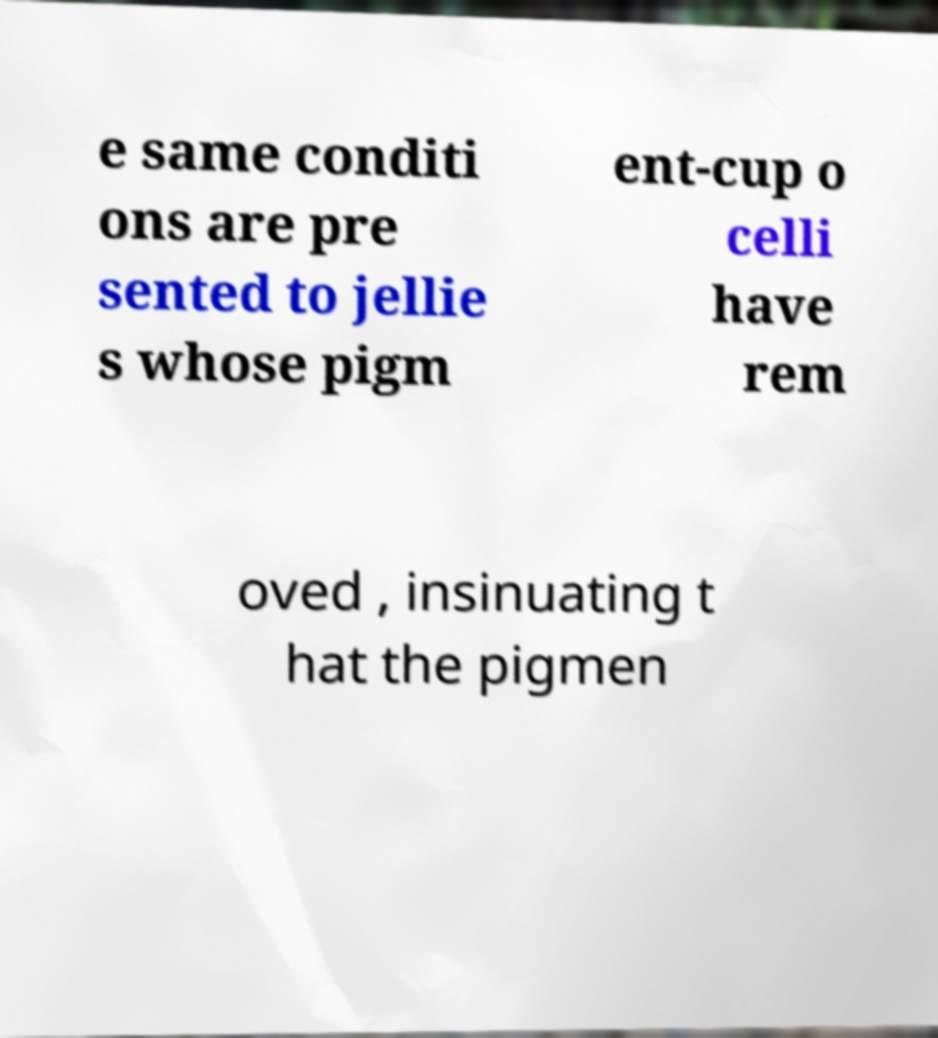I need the written content from this picture converted into text. Can you do that? e same conditi ons are pre sented to jellie s whose pigm ent-cup o celli have rem oved , insinuating t hat the pigmen 